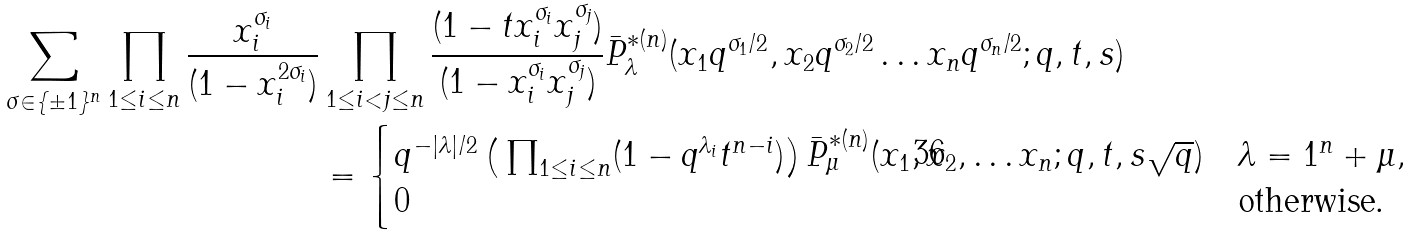<formula> <loc_0><loc_0><loc_500><loc_500>\sum _ { \sigma \in \{ \pm 1 \} ^ { n } } \prod _ { 1 \leq i \leq n } \frac { x _ { i } ^ { \sigma _ { i } } } { ( 1 - x _ { i } ^ { 2 \sigma _ { i } } ) } & \prod _ { 1 \leq i < j \leq n } \frac { ( 1 - t x _ { i } ^ { \sigma _ { i } } x _ { j } ^ { \sigma _ { j } } ) } { ( 1 - x _ { i } ^ { \sigma _ { i } } x _ { j } ^ { \sigma _ { j } } ) } \bar { P } ^ { * ( n ) } _ { \lambda } ( x _ { 1 } q ^ { \sigma _ { 1 } / 2 } , x _ { 2 } q ^ { \sigma _ { 2 } / 2 } \dots x _ { n } q ^ { \sigma _ { n } / 2 } ; q , t , s ) \\ & = \begin{cases} q ^ { - | \lambda | / 2 } \left ( \, \prod _ { 1 \leq i \leq n } ( 1 - q ^ { \lambda _ { i } } t ^ { n - i } ) \right ) \bar { P } ^ { * ( n ) } _ { \mu } ( x _ { 1 } , x _ { 2 } , \dots x _ { n } ; q , t , s \sqrt { q } ) & \lambda = 1 ^ { n } + \mu , \\ 0 & \text {otherwise.} \end{cases}</formula> 